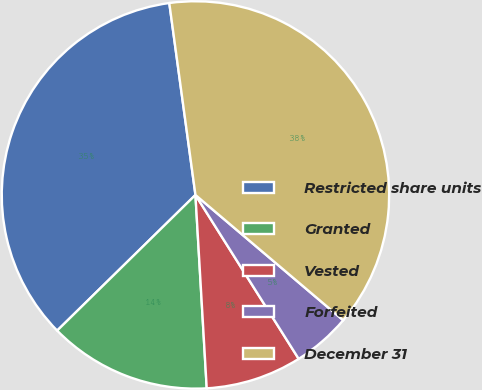Convert chart to OTSL. <chart><loc_0><loc_0><loc_500><loc_500><pie_chart><fcel>Restricted share units<fcel>Granted<fcel>Vested<fcel>Forfeited<fcel>December 31<nl><fcel>35.19%<fcel>13.58%<fcel>8.02%<fcel>4.86%<fcel>38.35%<nl></chart> 